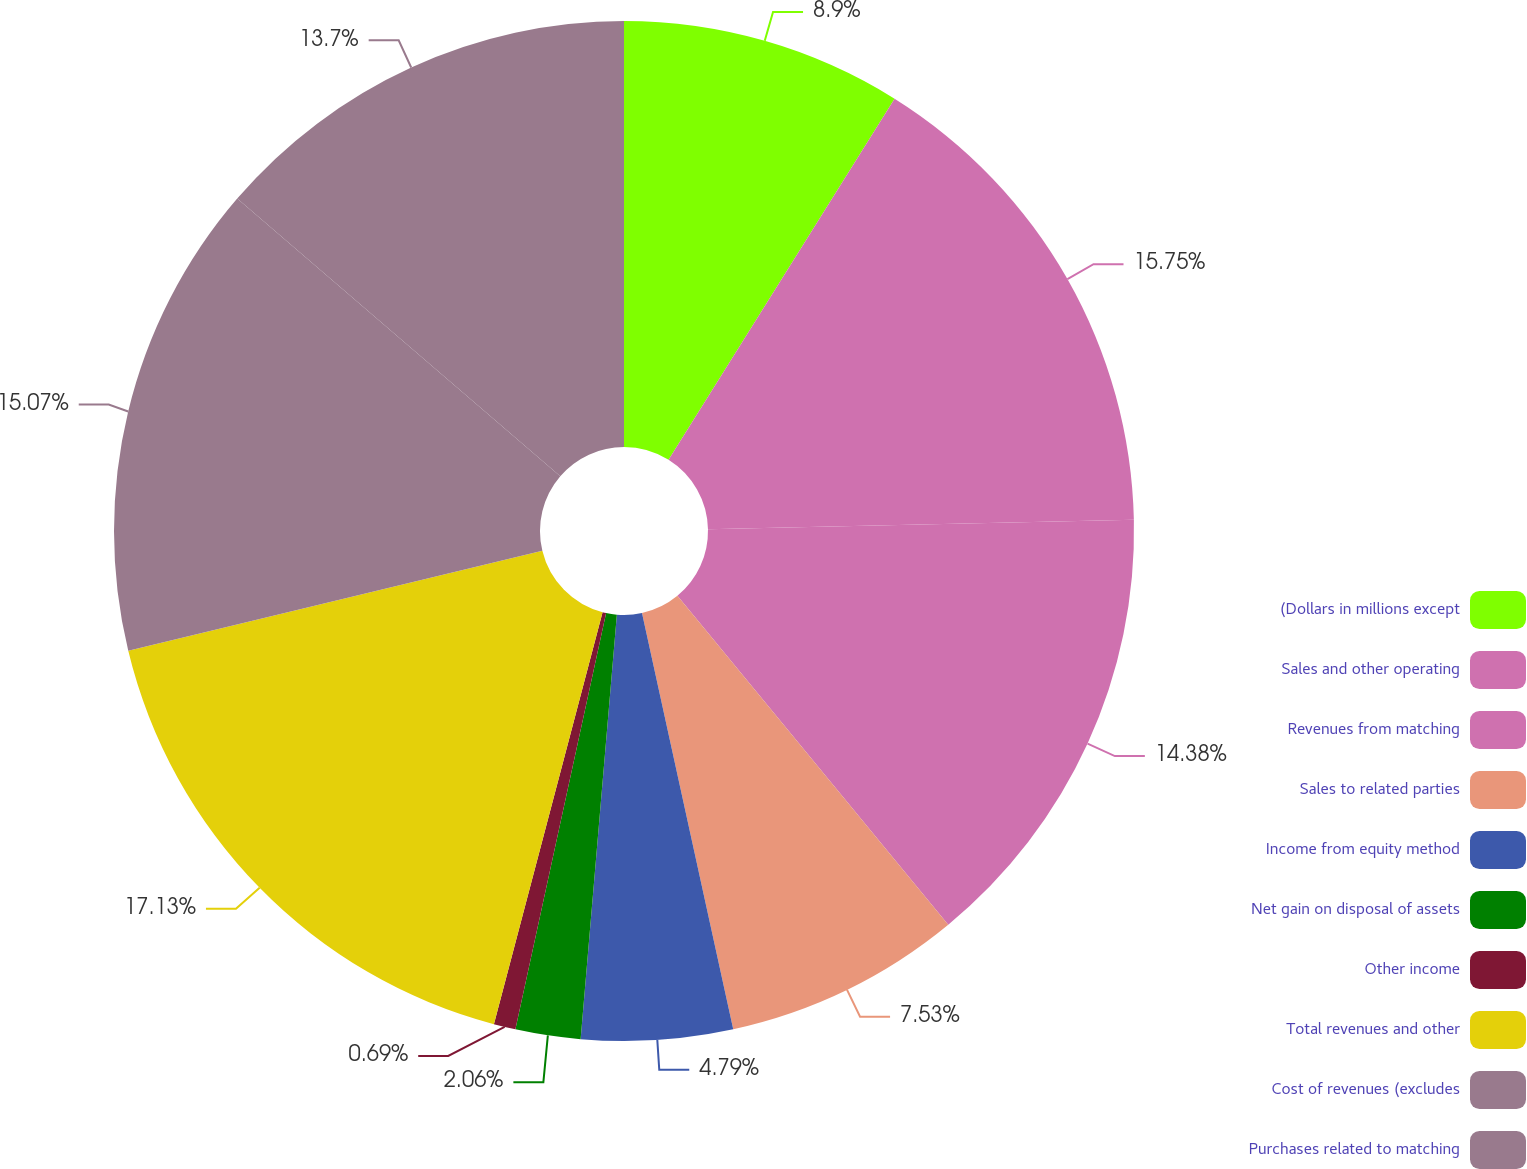Convert chart. <chart><loc_0><loc_0><loc_500><loc_500><pie_chart><fcel>(Dollars in millions except<fcel>Sales and other operating<fcel>Revenues from matching<fcel>Sales to related parties<fcel>Income from equity method<fcel>Net gain on disposal of assets<fcel>Other income<fcel>Total revenues and other<fcel>Cost of revenues (excludes<fcel>Purchases related to matching<nl><fcel>8.9%<fcel>15.75%<fcel>14.38%<fcel>7.53%<fcel>4.79%<fcel>2.06%<fcel>0.69%<fcel>17.12%<fcel>15.07%<fcel>13.7%<nl></chart> 